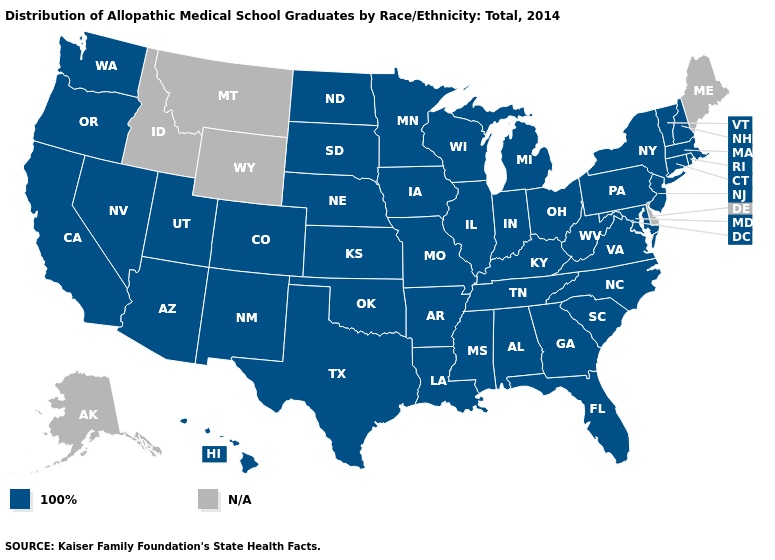Name the states that have a value in the range 100%?
Be succinct. Alabama, Arizona, Arkansas, California, Colorado, Connecticut, Florida, Georgia, Hawaii, Illinois, Indiana, Iowa, Kansas, Kentucky, Louisiana, Maryland, Massachusetts, Michigan, Minnesota, Mississippi, Missouri, Nebraska, Nevada, New Hampshire, New Jersey, New Mexico, New York, North Carolina, North Dakota, Ohio, Oklahoma, Oregon, Pennsylvania, Rhode Island, South Carolina, South Dakota, Tennessee, Texas, Utah, Vermont, Virginia, Washington, West Virginia, Wisconsin. What is the value of West Virginia?
Quick response, please. 100%. What is the lowest value in the USA?
Keep it brief. 100%. Name the states that have a value in the range N/A?
Answer briefly. Alaska, Delaware, Idaho, Maine, Montana, Wyoming. Name the states that have a value in the range 100%?
Write a very short answer. Alabama, Arizona, Arkansas, California, Colorado, Connecticut, Florida, Georgia, Hawaii, Illinois, Indiana, Iowa, Kansas, Kentucky, Louisiana, Maryland, Massachusetts, Michigan, Minnesota, Mississippi, Missouri, Nebraska, Nevada, New Hampshire, New Jersey, New Mexico, New York, North Carolina, North Dakota, Ohio, Oklahoma, Oregon, Pennsylvania, Rhode Island, South Carolina, South Dakota, Tennessee, Texas, Utah, Vermont, Virginia, Washington, West Virginia, Wisconsin. Name the states that have a value in the range N/A?
Short answer required. Alaska, Delaware, Idaho, Maine, Montana, Wyoming. Name the states that have a value in the range 100%?
Give a very brief answer. Alabama, Arizona, Arkansas, California, Colorado, Connecticut, Florida, Georgia, Hawaii, Illinois, Indiana, Iowa, Kansas, Kentucky, Louisiana, Maryland, Massachusetts, Michigan, Minnesota, Mississippi, Missouri, Nebraska, Nevada, New Hampshire, New Jersey, New Mexico, New York, North Carolina, North Dakota, Ohio, Oklahoma, Oregon, Pennsylvania, Rhode Island, South Carolina, South Dakota, Tennessee, Texas, Utah, Vermont, Virginia, Washington, West Virginia, Wisconsin. Is the legend a continuous bar?
Be succinct. No. What is the value of Nevada?
Answer briefly. 100%. Name the states that have a value in the range N/A?
Keep it brief. Alaska, Delaware, Idaho, Maine, Montana, Wyoming. What is the value of Louisiana?
Short answer required. 100%. 